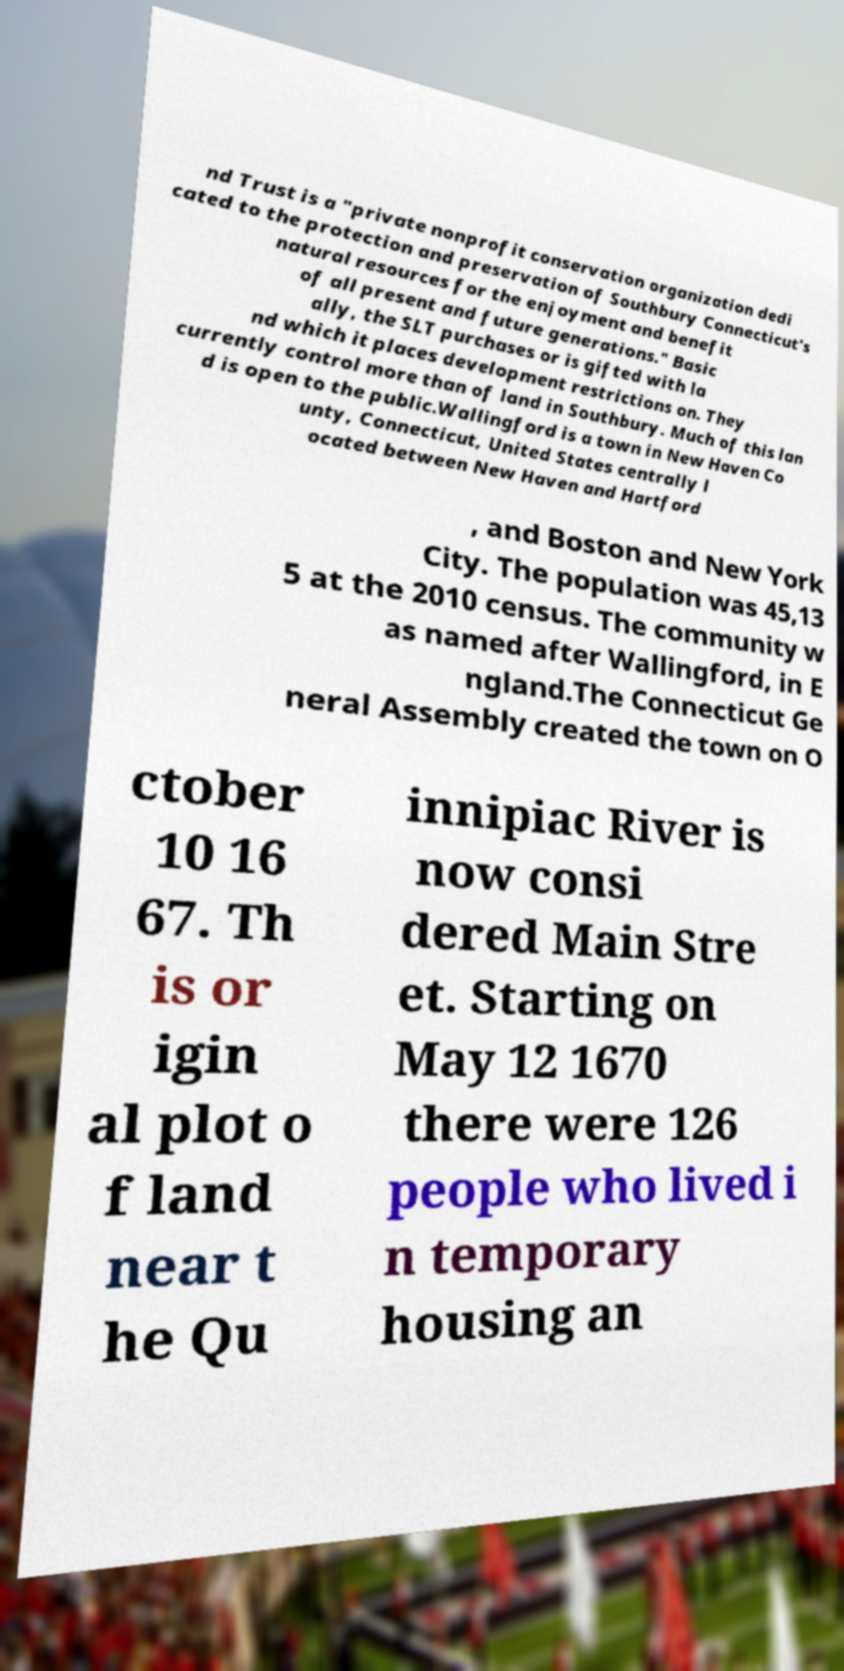Please identify and transcribe the text found in this image. nd Trust is a "private nonprofit conservation organization dedi cated to the protection and preservation of Southbury Connecticut's natural resources for the enjoyment and benefit of all present and future generations." Basic ally, the SLT purchases or is gifted with la nd which it places development restrictions on. They currently control more than of land in Southbury. Much of this lan d is open to the public.Wallingford is a town in New Haven Co unty, Connecticut, United States centrally l ocated between New Haven and Hartford , and Boston and New York City. The population was 45,13 5 at the 2010 census. The community w as named after Wallingford, in E ngland.The Connecticut Ge neral Assembly created the town on O ctober 10 16 67. Th is or igin al plot o f land near t he Qu innipiac River is now consi dered Main Stre et. Starting on May 12 1670 there were 126 people who lived i n temporary housing an 